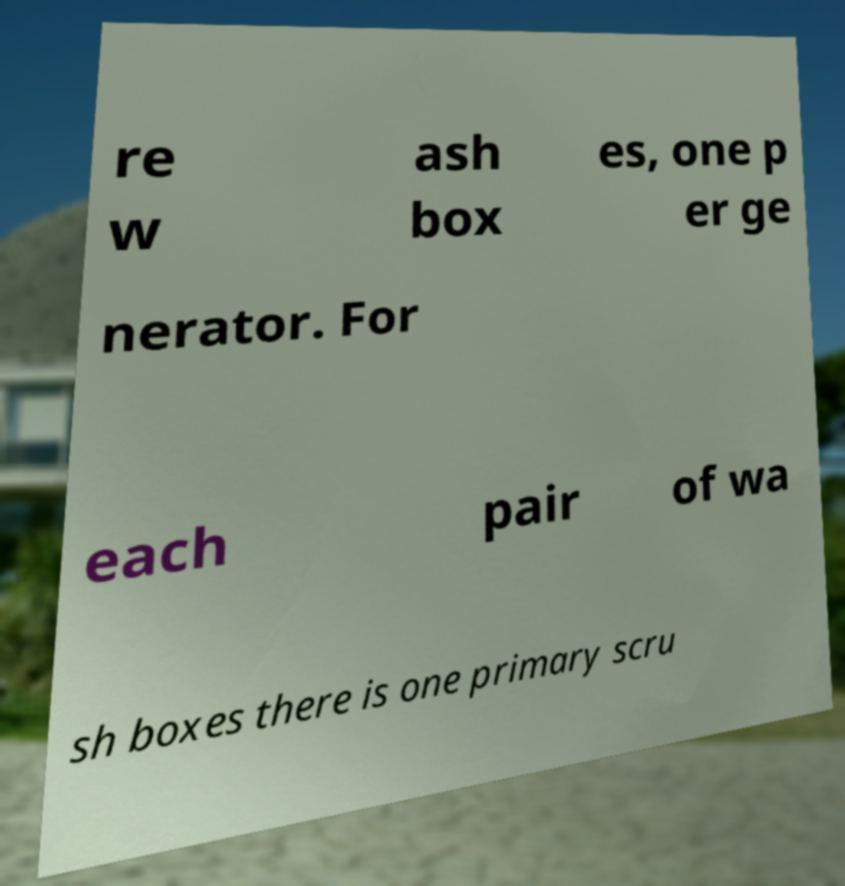For documentation purposes, I need the text within this image transcribed. Could you provide that? re w ash box es, one p er ge nerator. For each pair of wa sh boxes there is one primary scru 